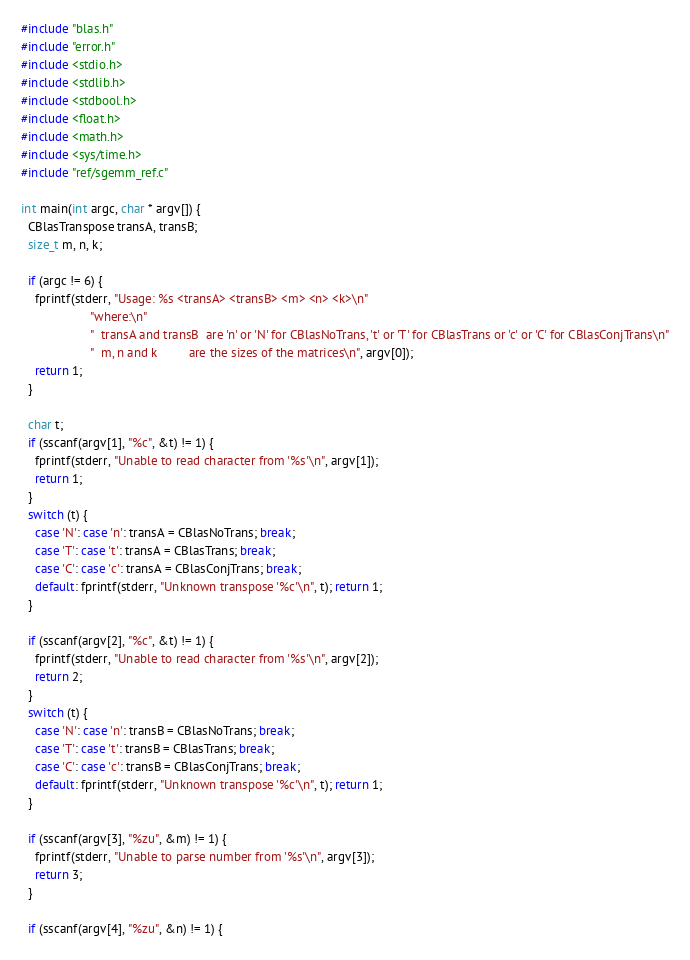<code> <loc_0><loc_0><loc_500><loc_500><_C_>#include "blas.h"
#include "error.h"
#include <stdio.h>
#include <stdlib.h>
#include <stdbool.h>
#include <float.h>
#include <math.h>
#include <sys/time.h>
#include "ref/sgemm_ref.c"

int main(int argc, char * argv[]) {
  CBlasTranspose transA, transB;
  size_t m, n, k;

  if (argc != 6) {
    fprintf(stderr, "Usage: %s <transA> <transB> <m> <n> <k>\n"
                    "where:\n"
                    "  transA and transB  are 'n' or 'N' for CBlasNoTrans, 't' or 'T' for CBlasTrans or 'c' or 'C' for CBlasConjTrans\n"
                    "  m, n and k         are the sizes of the matrices\n", argv[0]);
    return 1;
  }

  char t;
  if (sscanf(argv[1], "%c", &t) != 1) {
    fprintf(stderr, "Unable to read character from '%s'\n", argv[1]);
    return 1;
  }
  switch (t) {
    case 'N': case 'n': transA = CBlasNoTrans; break;
    case 'T': case 't': transA = CBlasTrans; break;
    case 'C': case 'c': transA = CBlasConjTrans; break;
    default: fprintf(stderr, "Unknown transpose '%c'\n", t); return 1;
  }

  if (sscanf(argv[2], "%c", &t) != 1) {
    fprintf(stderr, "Unable to read character from '%s'\n", argv[2]);
    return 2;
  }
  switch (t) {
    case 'N': case 'n': transB = CBlasNoTrans; break;
    case 'T': case 't': transB = CBlasTrans; break;
    case 'C': case 'c': transB = CBlasConjTrans; break;
    default: fprintf(stderr, "Unknown transpose '%c'\n", t); return 1;
  }

  if (sscanf(argv[3], "%zu", &m) != 1) {
    fprintf(stderr, "Unable to parse number from '%s'\n", argv[3]);
    return 3;
  }

  if (sscanf(argv[4], "%zu", &n) != 1) {</code> 